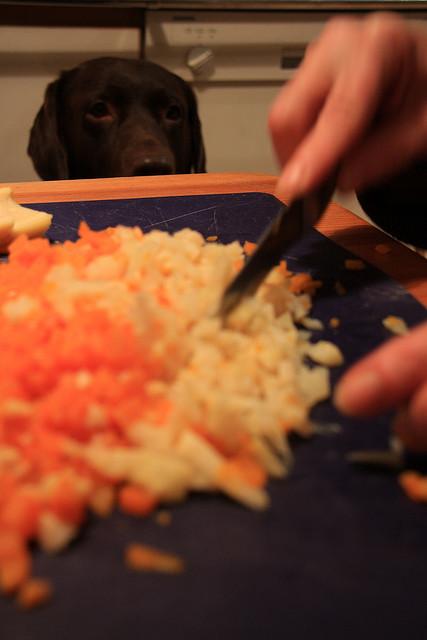Is the dog watching the food?
Answer briefly. Yes. What is the person holding in the right hand?
Answer briefly. Knife. When will this be served next?
Short answer required. Dinner. Name one vegetable in this dish?
Keep it brief. Carrots. What tool is being used?
Give a very brief answer. Knife. Where is the dog?
Write a very short answer. By table. 